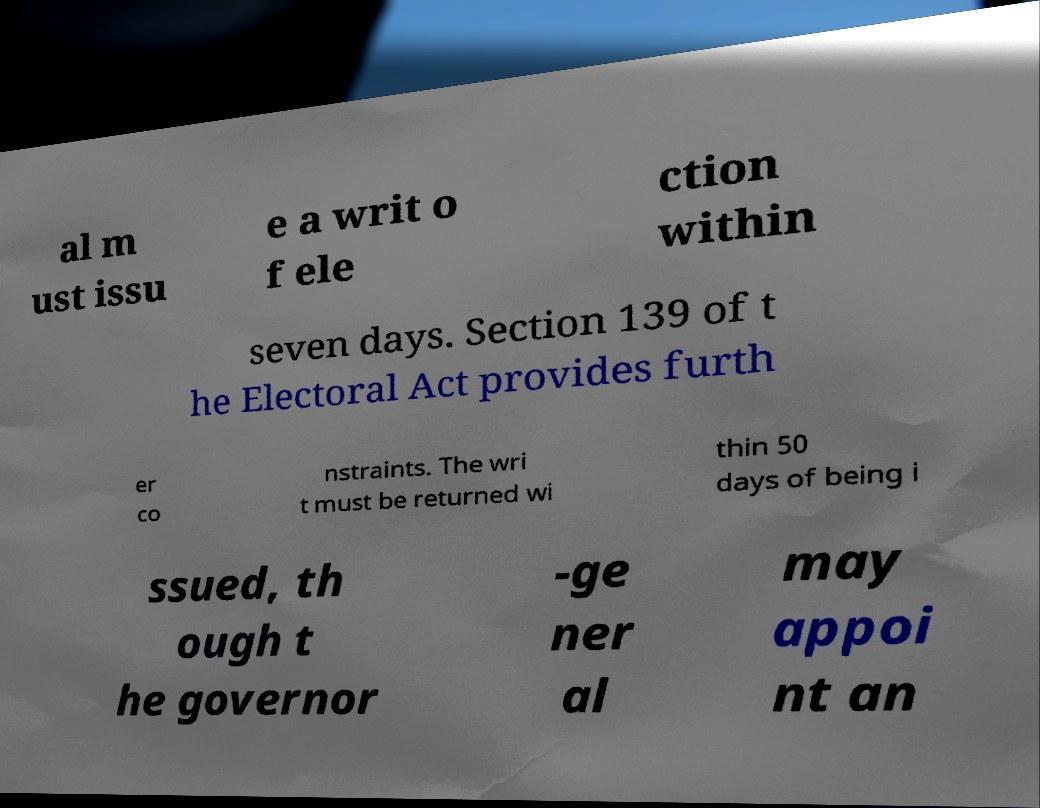There's text embedded in this image that I need extracted. Can you transcribe it verbatim? al m ust issu e a writ o f ele ction within seven days. Section 139 of t he Electoral Act provides furth er co nstraints. The wri t must be returned wi thin 50 days of being i ssued, th ough t he governor -ge ner al may appoi nt an 